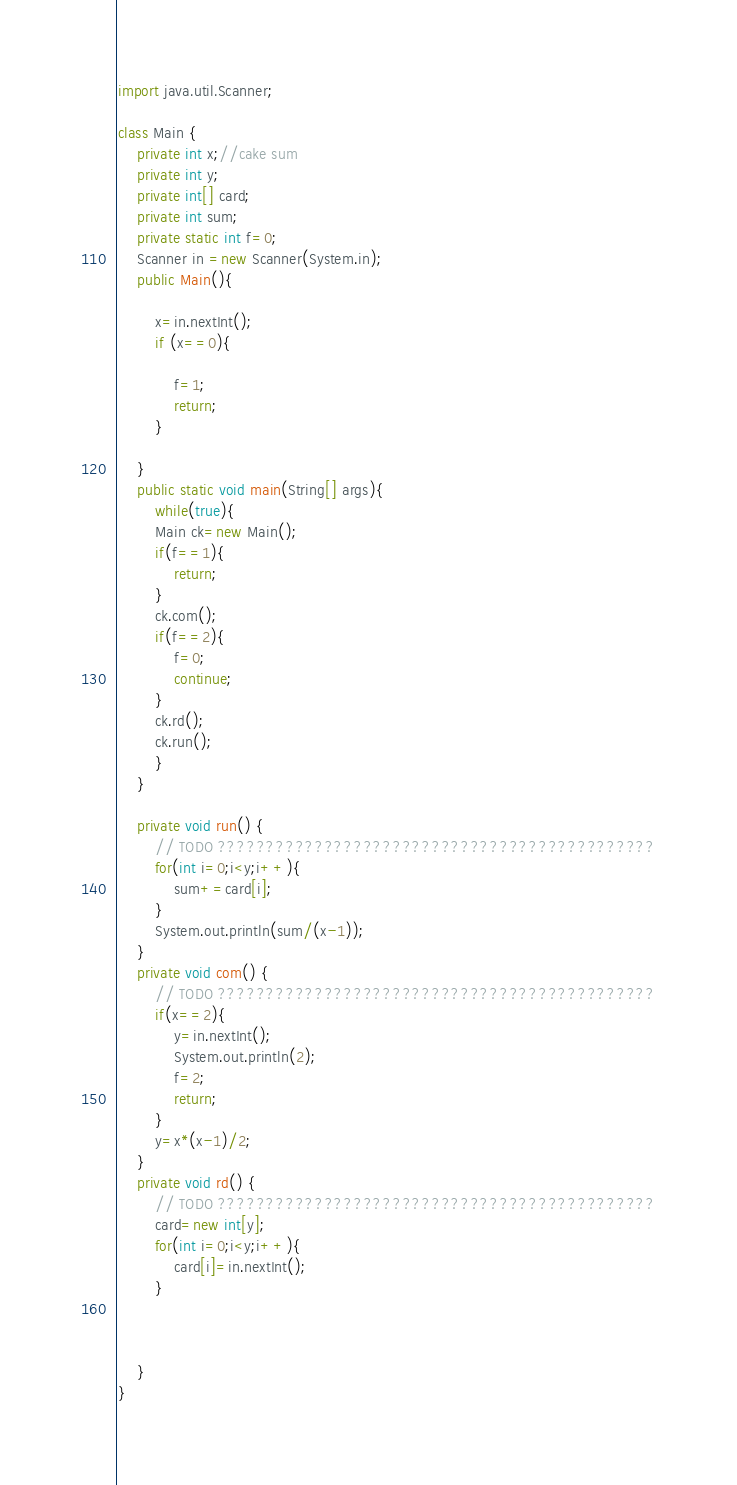Convert code to text. <code><loc_0><loc_0><loc_500><loc_500><_Java_>import java.util.Scanner;

class Main {
	private int x;//cake sum
	private int y;
	private int[] card;
	private int sum;
	private static int f=0;
	Scanner in =new Scanner(System.in);
	public Main(){
		
		x=in.nextInt();
		if (x==0){
			
			f=1;
			return;
		}
		
	}
	public static void main(String[] args){
		while(true){
		Main ck=new Main();
		if(f==1){
			return;
		}
		ck.com();
		if(f==2){
			f=0;
			continue;
		}
		ck.rd();
		ck.run();
		}
	}

	private void run() {
		// TODO ?????????????????????????????????????????????
		for(int i=0;i<y;i++){
			sum+=card[i];
		}
		System.out.println(sum/(x-1));
	}
	private void com() {
		// TODO ?????????????????????????????????????????????
		if(x==2){
			y=in.nextInt();
			System.out.println(2);
			f=2;
			return;
		}
		y=x*(x-1)/2;
	}
	private void rd() {
		// TODO ?????????????????????????????????????????????
		card=new int[y];
		for(int i=0;i<y;i++){
			card[i]=in.nextInt();
		}
		
		
		
	}
}</code> 